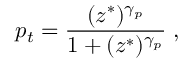<formula> <loc_0><loc_0><loc_500><loc_500>p _ { t } = \frac { ( z ^ { * } ) ^ { \gamma _ { p } } } { 1 + ( z ^ { * } ) ^ { \gamma _ { p } } } \, ,</formula> 